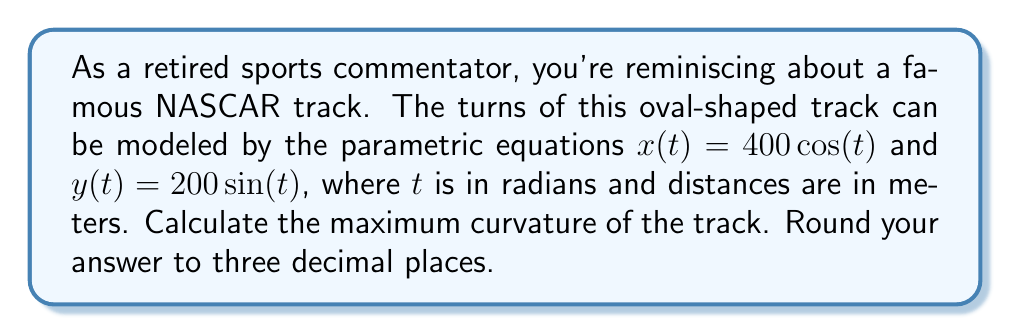Give your solution to this math problem. Let's approach this step-by-step:

1) The curvature $\kappa$ of a curve defined by parametric equations $x(t)$ and $y(t)$ is given by:

   $$\kappa = \frac{|x'y'' - y'x''|}{(x'^2 + y'^2)^{3/2}}$$

2) We need to find $x'$, $y'$, $x''$, and $y''$:
   
   $x' = -400\sin(t)$
   $y' = 200\cos(t)$
   $x'' = -400\cos(t)$
   $y'' = -200\sin(t)$

3) Substituting these into the curvature formula:

   $$\kappa = \frac{|(-400\sin(t))(-200\sin(t)) - (200\cos(t))(-400\cos(t))|}{((-400\sin(t))^2 + (200\cos(t))^2)^{3/2}}$$

4) Simplifying:

   $$\kappa = \frac{|80000\sin^2(t) + 80000\cos^2(t)|}{(160000\sin^2(t) + 40000\cos^2(t))^{3/2}}$$

5) The numerator simplifies to 80000 (since $\sin^2(t) + \cos^2(t) = 1$):

   $$\kappa = \frac{80000}{(160000\sin^2(t) + 40000\cos^2(t))^{3/2}}$$

6) The denominator is minimized when $\cos(t) = 0$ and $\sin(t) = 1$ (or vice versa), which occurs at the sharpest points of the turn. At these points:

   $$\kappa_{max} = \frac{80000}{(160000)^{3/2}} = \frac{1}{200}$$

7) Converting to decimal form and rounding to three decimal places:

   $$\kappa_{max} \approx 0.005$$
Answer: The maximum curvature of the track is approximately 0.005 m^(-1). 